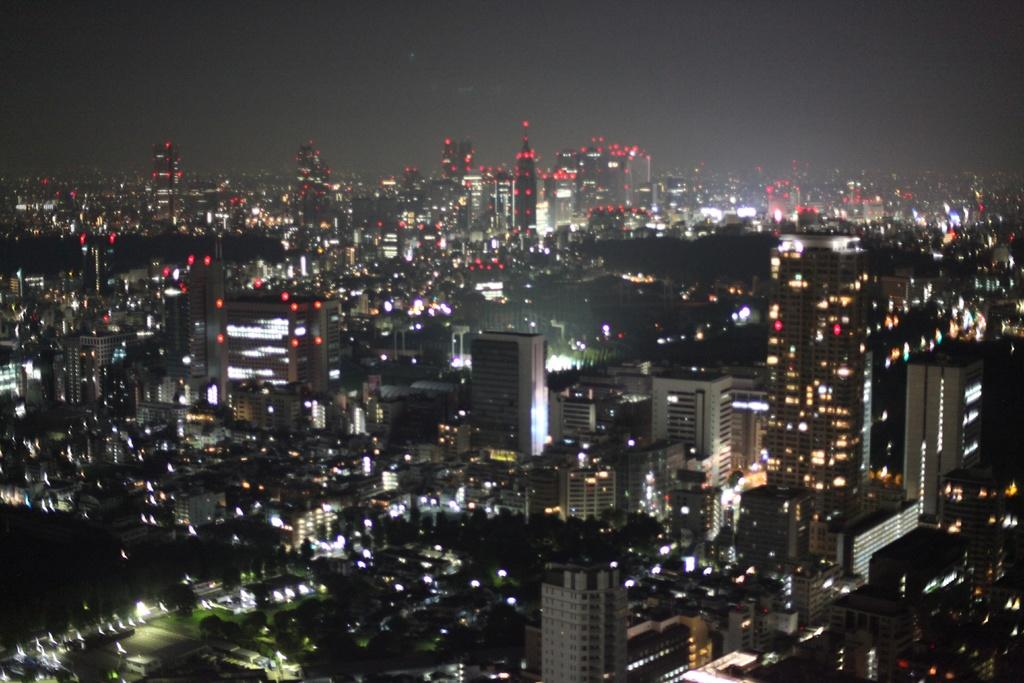What type of structures can be seen in the image? There are buildings in the image. What can be seen illuminating the buildings and surroundings? There are lights in the image. Can you determine the time of day based on the image? Yes, the image appears to be captured during night time. What type of trail can be seen leading to the throne in the image? There is no trail or throne present in the image; it features buildings and lights during night time. 